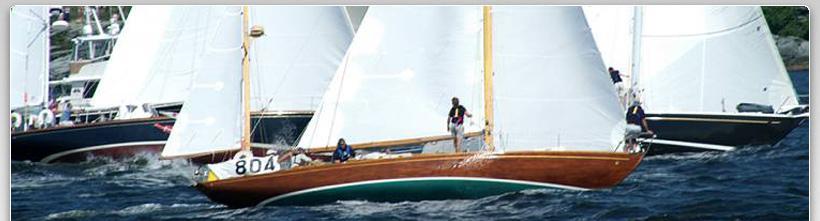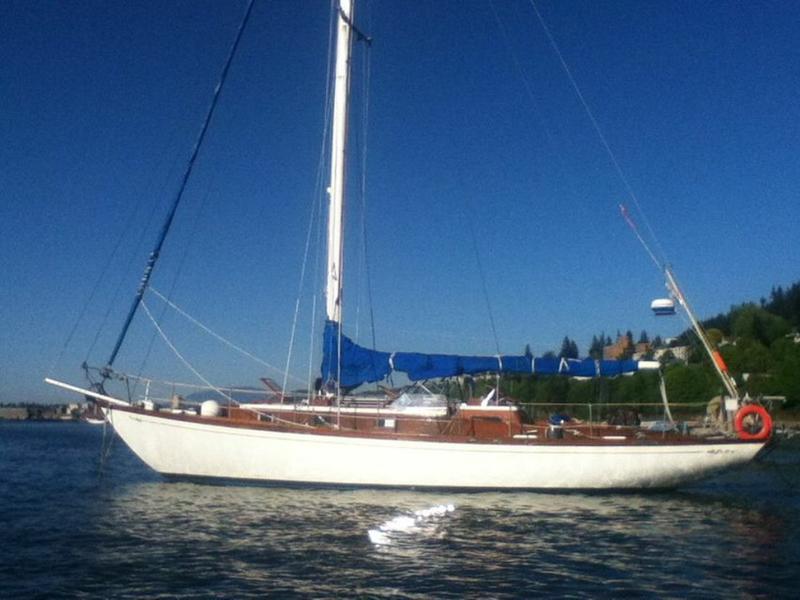The first image is the image on the left, the second image is the image on the right. Assess this claim about the two images: "There are multiple boats sailing in the left image.". Correct or not? Answer yes or no. Yes. The first image is the image on the left, the second image is the image on the right. Examine the images to the left and right. Is the description "In the left image, there are two boats, regardless of buoyancy." accurate? Answer yes or no. No. 